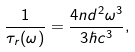<formula> <loc_0><loc_0><loc_500><loc_500>\frac { 1 } { \tau _ { r } ( \omega ) } = \frac { 4 n d ^ { 2 } \omega ^ { 3 } } { 3 \hbar { c } ^ { 3 } } ,</formula> 